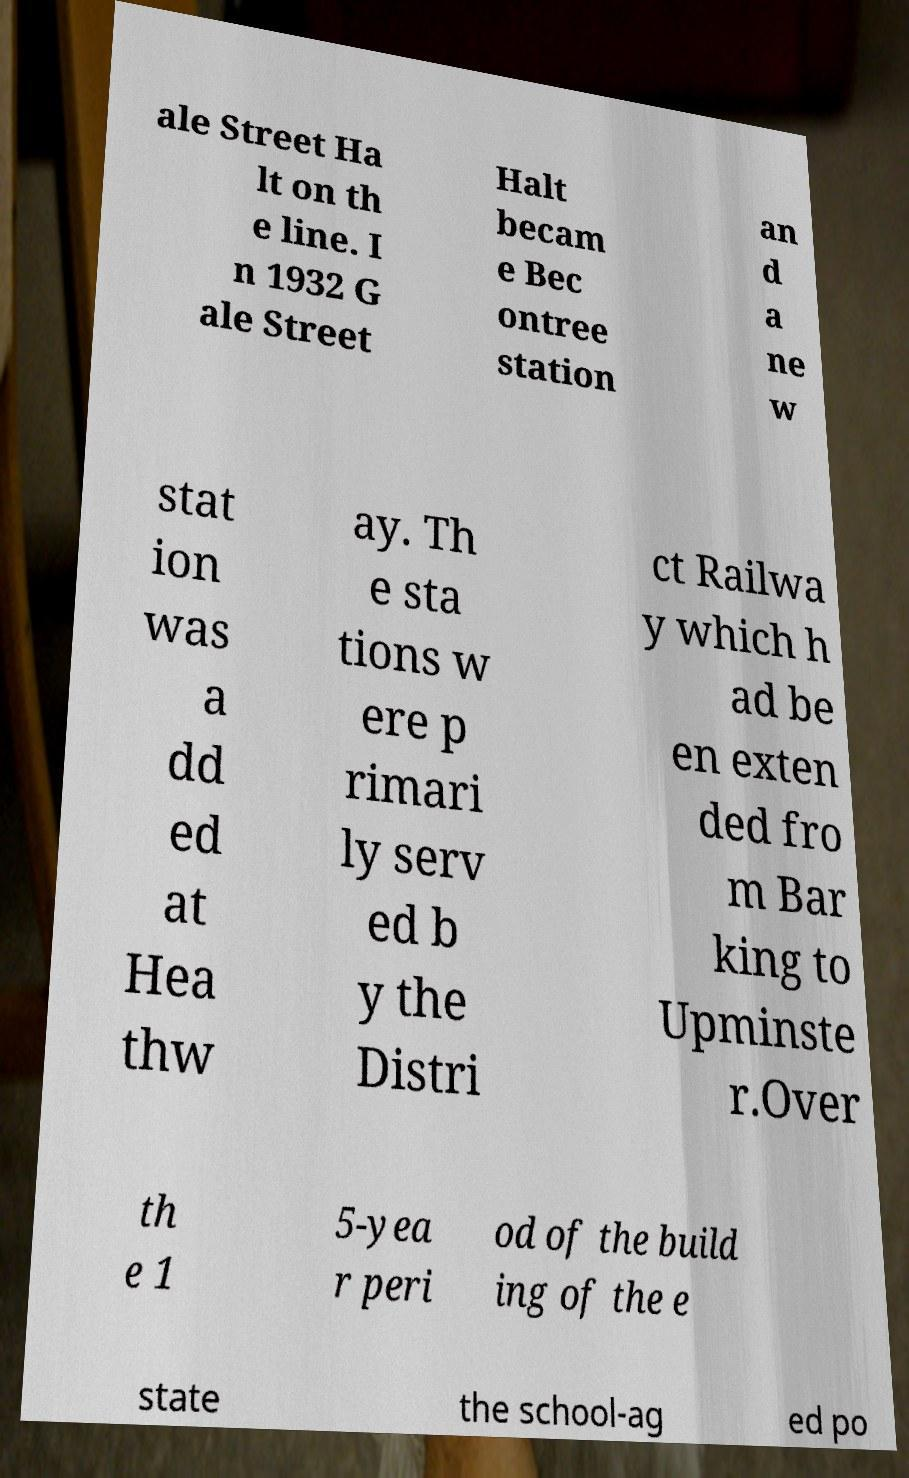Can you read and provide the text displayed in the image?This photo seems to have some interesting text. Can you extract and type it out for me? ale Street Ha lt on th e line. I n 1932 G ale Street Halt becam e Bec ontree station an d a ne w stat ion was a dd ed at Hea thw ay. Th e sta tions w ere p rimari ly serv ed b y the Distri ct Railwa y which h ad be en exten ded fro m Bar king to Upminste r.Over th e 1 5-yea r peri od of the build ing of the e state the school-ag ed po 